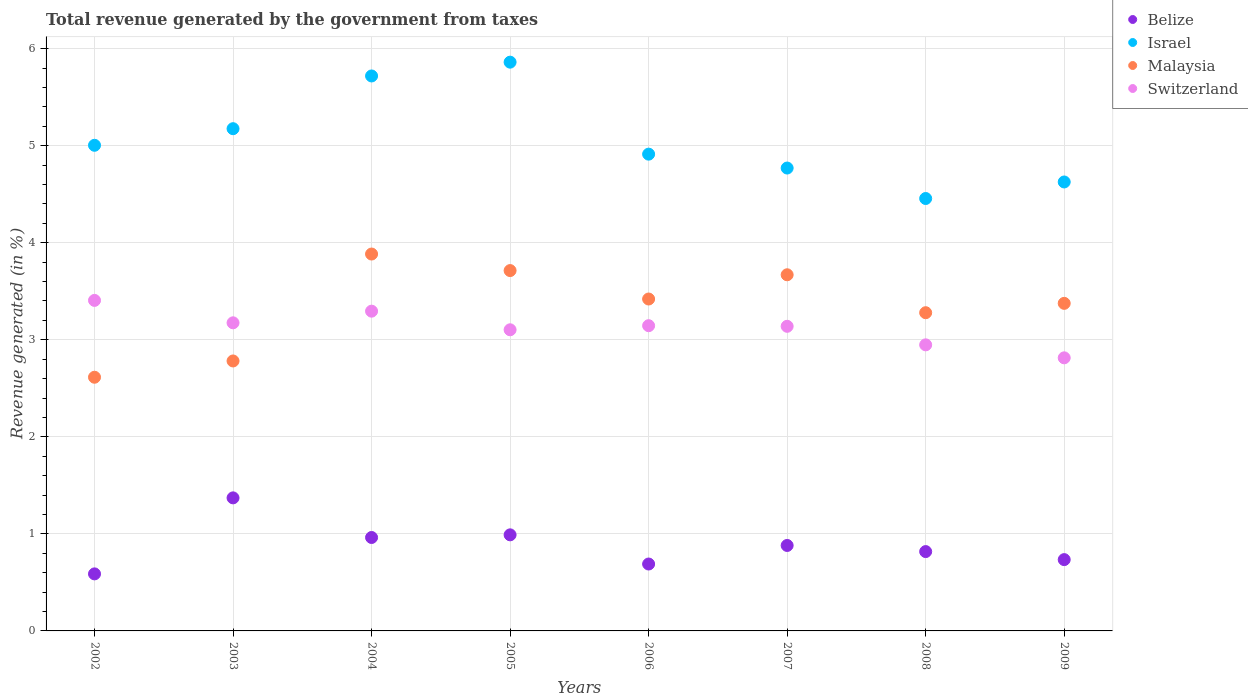How many different coloured dotlines are there?
Provide a succinct answer. 4. What is the total revenue generated in Switzerland in 2009?
Offer a terse response. 2.81. Across all years, what is the maximum total revenue generated in Belize?
Your answer should be compact. 1.37. Across all years, what is the minimum total revenue generated in Israel?
Provide a short and direct response. 4.46. In which year was the total revenue generated in Israel minimum?
Your answer should be very brief. 2008. What is the total total revenue generated in Israel in the graph?
Provide a short and direct response. 40.52. What is the difference between the total revenue generated in Malaysia in 2006 and that in 2007?
Make the answer very short. -0.25. What is the difference between the total revenue generated in Israel in 2008 and the total revenue generated in Belize in 2007?
Ensure brevity in your answer.  3.58. What is the average total revenue generated in Malaysia per year?
Your answer should be very brief. 3.34. In the year 2009, what is the difference between the total revenue generated in Malaysia and total revenue generated in Belize?
Give a very brief answer. 2.64. In how many years, is the total revenue generated in Malaysia greater than 2.4 %?
Keep it short and to the point. 8. What is the ratio of the total revenue generated in Switzerland in 2003 to that in 2004?
Offer a very short reply. 0.96. What is the difference between the highest and the second highest total revenue generated in Switzerland?
Give a very brief answer. 0.11. What is the difference between the highest and the lowest total revenue generated in Belize?
Keep it short and to the point. 0.78. In how many years, is the total revenue generated in Israel greater than the average total revenue generated in Israel taken over all years?
Offer a very short reply. 3. Is it the case that in every year, the sum of the total revenue generated in Israel and total revenue generated in Malaysia  is greater than the sum of total revenue generated in Belize and total revenue generated in Switzerland?
Your answer should be compact. Yes. Is it the case that in every year, the sum of the total revenue generated in Switzerland and total revenue generated in Belize  is greater than the total revenue generated in Malaysia?
Provide a short and direct response. Yes. Does the total revenue generated in Switzerland monotonically increase over the years?
Offer a terse response. No. Is the total revenue generated in Malaysia strictly less than the total revenue generated in Switzerland over the years?
Give a very brief answer. No. Are the values on the major ticks of Y-axis written in scientific E-notation?
Offer a very short reply. No. Does the graph contain any zero values?
Your answer should be very brief. No. Does the graph contain grids?
Your answer should be compact. Yes. Where does the legend appear in the graph?
Make the answer very short. Top right. How many legend labels are there?
Offer a very short reply. 4. What is the title of the graph?
Offer a terse response. Total revenue generated by the government from taxes. Does "Bahrain" appear as one of the legend labels in the graph?
Provide a short and direct response. No. What is the label or title of the X-axis?
Provide a short and direct response. Years. What is the label or title of the Y-axis?
Make the answer very short. Revenue generated (in %). What is the Revenue generated (in %) of Belize in 2002?
Provide a succinct answer. 0.59. What is the Revenue generated (in %) of Israel in 2002?
Keep it short and to the point. 5. What is the Revenue generated (in %) of Malaysia in 2002?
Offer a terse response. 2.61. What is the Revenue generated (in %) of Switzerland in 2002?
Ensure brevity in your answer.  3.41. What is the Revenue generated (in %) in Belize in 2003?
Make the answer very short. 1.37. What is the Revenue generated (in %) in Israel in 2003?
Offer a very short reply. 5.17. What is the Revenue generated (in %) in Malaysia in 2003?
Provide a succinct answer. 2.78. What is the Revenue generated (in %) in Switzerland in 2003?
Keep it short and to the point. 3.17. What is the Revenue generated (in %) of Belize in 2004?
Offer a very short reply. 0.96. What is the Revenue generated (in %) in Israel in 2004?
Provide a short and direct response. 5.72. What is the Revenue generated (in %) in Malaysia in 2004?
Keep it short and to the point. 3.88. What is the Revenue generated (in %) of Switzerland in 2004?
Your answer should be compact. 3.29. What is the Revenue generated (in %) in Belize in 2005?
Provide a succinct answer. 0.99. What is the Revenue generated (in %) in Israel in 2005?
Give a very brief answer. 5.86. What is the Revenue generated (in %) in Malaysia in 2005?
Give a very brief answer. 3.71. What is the Revenue generated (in %) of Switzerland in 2005?
Provide a short and direct response. 3.1. What is the Revenue generated (in %) of Belize in 2006?
Make the answer very short. 0.69. What is the Revenue generated (in %) in Israel in 2006?
Ensure brevity in your answer.  4.91. What is the Revenue generated (in %) in Malaysia in 2006?
Offer a very short reply. 3.42. What is the Revenue generated (in %) of Switzerland in 2006?
Your response must be concise. 3.15. What is the Revenue generated (in %) in Belize in 2007?
Offer a terse response. 0.88. What is the Revenue generated (in %) in Israel in 2007?
Keep it short and to the point. 4.77. What is the Revenue generated (in %) of Malaysia in 2007?
Ensure brevity in your answer.  3.67. What is the Revenue generated (in %) in Switzerland in 2007?
Offer a very short reply. 3.14. What is the Revenue generated (in %) in Belize in 2008?
Your response must be concise. 0.82. What is the Revenue generated (in %) in Israel in 2008?
Offer a very short reply. 4.46. What is the Revenue generated (in %) in Malaysia in 2008?
Give a very brief answer. 3.28. What is the Revenue generated (in %) of Switzerland in 2008?
Offer a very short reply. 2.95. What is the Revenue generated (in %) in Belize in 2009?
Provide a succinct answer. 0.73. What is the Revenue generated (in %) in Israel in 2009?
Your answer should be very brief. 4.63. What is the Revenue generated (in %) of Malaysia in 2009?
Your response must be concise. 3.38. What is the Revenue generated (in %) in Switzerland in 2009?
Ensure brevity in your answer.  2.81. Across all years, what is the maximum Revenue generated (in %) of Belize?
Your response must be concise. 1.37. Across all years, what is the maximum Revenue generated (in %) in Israel?
Provide a short and direct response. 5.86. Across all years, what is the maximum Revenue generated (in %) in Malaysia?
Your answer should be compact. 3.88. Across all years, what is the maximum Revenue generated (in %) of Switzerland?
Ensure brevity in your answer.  3.41. Across all years, what is the minimum Revenue generated (in %) of Belize?
Keep it short and to the point. 0.59. Across all years, what is the minimum Revenue generated (in %) in Israel?
Your answer should be compact. 4.46. Across all years, what is the minimum Revenue generated (in %) of Malaysia?
Provide a short and direct response. 2.61. Across all years, what is the minimum Revenue generated (in %) in Switzerland?
Ensure brevity in your answer.  2.81. What is the total Revenue generated (in %) of Belize in the graph?
Provide a succinct answer. 7.03. What is the total Revenue generated (in %) in Israel in the graph?
Make the answer very short. 40.52. What is the total Revenue generated (in %) of Malaysia in the graph?
Ensure brevity in your answer.  26.74. What is the total Revenue generated (in %) in Switzerland in the graph?
Give a very brief answer. 25.02. What is the difference between the Revenue generated (in %) of Belize in 2002 and that in 2003?
Your answer should be very brief. -0.78. What is the difference between the Revenue generated (in %) of Israel in 2002 and that in 2003?
Ensure brevity in your answer.  -0.17. What is the difference between the Revenue generated (in %) in Malaysia in 2002 and that in 2003?
Offer a very short reply. -0.17. What is the difference between the Revenue generated (in %) of Switzerland in 2002 and that in 2003?
Offer a very short reply. 0.23. What is the difference between the Revenue generated (in %) in Belize in 2002 and that in 2004?
Your response must be concise. -0.38. What is the difference between the Revenue generated (in %) in Israel in 2002 and that in 2004?
Keep it short and to the point. -0.71. What is the difference between the Revenue generated (in %) in Malaysia in 2002 and that in 2004?
Make the answer very short. -1.27. What is the difference between the Revenue generated (in %) of Switzerland in 2002 and that in 2004?
Your answer should be compact. 0.11. What is the difference between the Revenue generated (in %) of Belize in 2002 and that in 2005?
Provide a succinct answer. -0.4. What is the difference between the Revenue generated (in %) of Israel in 2002 and that in 2005?
Offer a terse response. -0.86. What is the difference between the Revenue generated (in %) of Malaysia in 2002 and that in 2005?
Offer a terse response. -1.1. What is the difference between the Revenue generated (in %) of Switzerland in 2002 and that in 2005?
Provide a succinct answer. 0.3. What is the difference between the Revenue generated (in %) of Belize in 2002 and that in 2006?
Provide a short and direct response. -0.1. What is the difference between the Revenue generated (in %) of Israel in 2002 and that in 2006?
Make the answer very short. 0.09. What is the difference between the Revenue generated (in %) in Malaysia in 2002 and that in 2006?
Your answer should be very brief. -0.81. What is the difference between the Revenue generated (in %) in Switzerland in 2002 and that in 2006?
Provide a succinct answer. 0.26. What is the difference between the Revenue generated (in %) of Belize in 2002 and that in 2007?
Provide a succinct answer. -0.29. What is the difference between the Revenue generated (in %) in Israel in 2002 and that in 2007?
Make the answer very short. 0.23. What is the difference between the Revenue generated (in %) of Malaysia in 2002 and that in 2007?
Keep it short and to the point. -1.06. What is the difference between the Revenue generated (in %) in Switzerland in 2002 and that in 2007?
Ensure brevity in your answer.  0.27. What is the difference between the Revenue generated (in %) in Belize in 2002 and that in 2008?
Your answer should be very brief. -0.23. What is the difference between the Revenue generated (in %) of Israel in 2002 and that in 2008?
Offer a terse response. 0.55. What is the difference between the Revenue generated (in %) of Malaysia in 2002 and that in 2008?
Offer a very short reply. -0.67. What is the difference between the Revenue generated (in %) of Switzerland in 2002 and that in 2008?
Your answer should be compact. 0.46. What is the difference between the Revenue generated (in %) in Belize in 2002 and that in 2009?
Provide a succinct answer. -0.15. What is the difference between the Revenue generated (in %) in Israel in 2002 and that in 2009?
Offer a terse response. 0.38. What is the difference between the Revenue generated (in %) of Malaysia in 2002 and that in 2009?
Your answer should be compact. -0.76. What is the difference between the Revenue generated (in %) of Switzerland in 2002 and that in 2009?
Keep it short and to the point. 0.59. What is the difference between the Revenue generated (in %) of Belize in 2003 and that in 2004?
Provide a succinct answer. 0.41. What is the difference between the Revenue generated (in %) in Israel in 2003 and that in 2004?
Give a very brief answer. -0.54. What is the difference between the Revenue generated (in %) of Malaysia in 2003 and that in 2004?
Make the answer very short. -1.1. What is the difference between the Revenue generated (in %) in Switzerland in 2003 and that in 2004?
Your answer should be compact. -0.12. What is the difference between the Revenue generated (in %) in Belize in 2003 and that in 2005?
Provide a short and direct response. 0.38. What is the difference between the Revenue generated (in %) of Israel in 2003 and that in 2005?
Provide a succinct answer. -0.69. What is the difference between the Revenue generated (in %) in Malaysia in 2003 and that in 2005?
Offer a terse response. -0.93. What is the difference between the Revenue generated (in %) in Switzerland in 2003 and that in 2005?
Your answer should be very brief. 0.07. What is the difference between the Revenue generated (in %) of Belize in 2003 and that in 2006?
Offer a very short reply. 0.68. What is the difference between the Revenue generated (in %) of Israel in 2003 and that in 2006?
Your response must be concise. 0.26. What is the difference between the Revenue generated (in %) of Malaysia in 2003 and that in 2006?
Ensure brevity in your answer.  -0.64. What is the difference between the Revenue generated (in %) in Switzerland in 2003 and that in 2006?
Provide a succinct answer. 0.03. What is the difference between the Revenue generated (in %) in Belize in 2003 and that in 2007?
Make the answer very short. 0.49. What is the difference between the Revenue generated (in %) in Israel in 2003 and that in 2007?
Your answer should be very brief. 0.41. What is the difference between the Revenue generated (in %) in Malaysia in 2003 and that in 2007?
Provide a succinct answer. -0.89. What is the difference between the Revenue generated (in %) in Switzerland in 2003 and that in 2007?
Keep it short and to the point. 0.04. What is the difference between the Revenue generated (in %) of Belize in 2003 and that in 2008?
Ensure brevity in your answer.  0.55. What is the difference between the Revenue generated (in %) of Israel in 2003 and that in 2008?
Keep it short and to the point. 0.72. What is the difference between the Revenue generated (in %) of Malaysia in 2003 and that in 2008?
Make the answer very short. -0.5. What is the difference between the Revenue generated (in %) of Switzerland in 2003 and that in 2008?
Ensure brevity in your answer.  0.23. What is the difference between the Revenue generated (in %) in Belize in 2003 and that in 2009?
Your response must be concise. 0.64. What is the difference between the Revenue generated (in %) of Israel in 2003 and that in 2009?
Your answer should be compact. 0.55. What is the difference between the Revenue generated (in %) in Malaysia in 2003 and that in 2009?
Provide a short and direct response. -0.59. What is the difference between the Revenue generated (in %) in Switzerland in 2003 and that in 2009?
Your answer should be compact. 0.36. What is the difference between the Revenue generated (in %) in Belize in 2004 and that in 2005?
Make the answer very short. -0.03. What is the difference between the Revenue generated (in %) of Israel in 2004 and that in 2005?
Offer a terse response. -0.14. What is the difference between the Revenue generated (in %) of Malaysia in 2004 and that in 2005?
Make the answer very short. 0.17. What is the difference between the Revenue generated (in %) of Switzerland in 2004 and that in 2005?
Your response must be concise. 0.19. What is the difference between the Revenue generated (in %) in Belize in 2004 and that in 2006?
Your answer should be compact. 0.27. What is the difference between the Revenue generated (in %) of Israel in 2004 and that in 2006?
Provide a succinct answer. 0.81. What is the difference between the Revenue generated (in %) in Malaysia in 2004 and that in 2006?
Give a very brief answer. 0.46. What is the difference between the Revenue generated (in %) in Switzerland in 2004 and that in 2006?
Your response must be concise. 0.15. What is the difference between the Revenue generated (in %) in Belize in 2004 and that in 2007?
Your answer should be very brief. 0.08. What is the difference between the Revenue generated (in %) in Israel in 2004 and that in 2007?
Ensure brevity in your answer.  0.95. What is the difference between the Revenue generated (in %) of Malaysia in 2004 and that in 2007?
Your response must be concise. 0.21. What is the difference between the Revenue generated (in %) of Switzerland in 2004 and that in 2007?
Your answer should be compact. 0.16. What is the difference between the Revenue generated (in %) in Belize in 2004 and that in 2008?
Provide a short and direct response. 0.15. What is the difference between the Revenue generated (in %) of Israel in 2004 and that in 2008?
Provide a short and direct response. 1.26. What is the difference between the Revenue generated (in %) of Malaysia in 2004 and that in 2008?
Your answer should be compact. 0.6. What is the difference between the Revenue generated (in %) in Switzerland in 2004 and that in 2008?
Your answer should be very brief. 0.35. What is the difference between the Revenue generated (in %) of Belize in 2004 and that in 2009?
Offer a terse response. 0.23. What is the difference between the Revenue generated (in %) of Israel in 2004 and that in 2009?
Keep it short and to the point. 1.09. What is the difference between the Revenue generated (in %) of Malaysia in 2004 and that in 2009?
Provide a short and direct response. 0.51. What is the difference between the Revenue generated (in %) of Switzerland in 2004 and that in 2009?
Offer a very short reply. 0.48. What is the difference between the Revenue generated (in %) of Belize in 2005 and that in 2006?
Make the answer very short. 0.3. What is the difference between the Revenue generated (in %) in Israel in 2005 and that in 2006?
Ensure brevity in your answer.  0.95. What is the difference between the Revenue generated (in %) in Malaysia in 2005 and that in 2006?
Provide a succinct answer. 0.29. What is the difference between the Revenue generated (in %) of Switzerland in 2005 and that in 2006?
Your answer should be compact. -0.04. What is the difference between the Revenue generated (in %) in Belize in 2005 and that in 2007?
Provide a succinct answer. 0.11. What is the difference between the Revenue generated (in %) of Israel in 2005 and that in 2007?
Make the answer very short. 1.09. What is the difference between the Revenue generated (in %) of Malaysia in 2005 and that in 2007?
Provide a succinct answer. 0.04. What is the difference between the Revenue generated (in %) of Switzerland in 2005 and that in 2007?
Your answer should be very brief. -0.04. What is the difference between the Revenue generated (in %) of Belize in 2005 and that in 2008?
Your response must be concise. 0.17. What is the difference between the Revenue generated (in %) of Israel in 2005 and that in 2008?
Provide a succinct answer. 1.4. What is the difference between the Revenue generated (in %) of Malaysia in 2005 and that in 2008?
Provide a succinct answer. 0.43. What is the difference between the Revenue generated (in %) of Switzerland in 2005 and that in 2008?
Your response must be concise. 0.16. What is the difference between the Revenue generated (in %) in Belize in 2005 and that in 2009?
Keep it short and to the point. 0.26. What is the difference between the Revenue generated (in %) in Israel in 2005 and that in 2009?
Ensure brevity in your answer.  1.23. What is the difference between the Revenue generated (in %) of Malaysia in 2005 and that in 2009?
Your answer should be compact. 0.34. What is the difference between the Revenue generated (in %) in Switzerland in 2005 and that in 2009?
Give a very brief answer. 0.29. What is the difference between the Revenue generated (in %) of Belize in 2006 and that in 2007?
Offer a very short reply. -0.19. What is the difference between the Revenue generated (in %) in Israel in 2006 and that in 2007?
Offer a very short reply. 0.14. What is the difference between the Revenue generated (in %) in Malaysia in 2006 and that in 2007?
Your answer should be compact. -0.25. What is the difference between the Revenue generated (in %) of Switzerland in 2006 and that in 2007?
Make the answer very short. 0.01. What is the difference between the Revenue generated (in %) of Belize in 2006 and that in 2008?
Ensure brevity in your answer.  -0.13. What is the difference between the Revenue generated (in %) of Israel in 2006 and that in 2008?
Your answer should be compact. 0.46. What is the difference between the Revenue generated (in %) in Malaysia in 2006 and that in 2008?
Give a very brief answer. 0.14. What is the difference between the Revenue generated (in %) in Switzerland in 2006 and that in 2008?
Make the answer very short. 0.2. What is the difference between the Revenue generated (in %) in Belize in 2006 and that in 2009?
Provide a short and direct response. -0.05. What is the difference between the Revenue generated (in %) of Israel in 2006 and that in 2009?
Give a very brief answer. 0.29. What is the difference between the Revenue generated (in %) of Malaysia in 2006 and that in 2009?
Provide a succinct answer. 0.04. What is the difference between the Revenue generated (in %) in Switzerland in 2006 and that in 2009?
Your answer should be very brief. 0.33. What is the difference between the Revenue generated (in %) in Belize in 2007 and that in 2008?
Ensure brevity in your answer.  0.06. What is the difference between the Revenue generated (in %) of Israel in 2007 and that in 2008?
Provide a succinct answer. 0.31. What is the difference between the Revenue generated (in %) in Malaysia in 2007 and that in 2008?
Make the answer very short. 0.39. What is the difference between the Revenue generated (in %) of Switzerland in 2007 and that in 2008?
Your answer should be very brief. 0.19. What is the difference between the Revenue generated (in %) in Belize in 2007 and that in 2009?
Give a very brief answer. 0.15. What is the difference between the Revenue generated (in %) in Israel in 2007 and that in 2009?
Ensure brevity in your answer.  0.14. What is the difference between the Revenue generated (in %) of Malaysia in 2007 and that in 2009?
Your response must be concise. 0.29. What is the difference between the Revenue generated (in %) of Switzerland in 2007 and that in 2009?
Your response must be concise. 0.32. What is the difference between the Revenue generated (in %) of Belize in 2008 and that in 2009?
Provide a succinct answer. 0.08. What is the difference between the Revenue generated (in %) in Israel in 2008 and that in 2009?
Your answer should be very brief. -0.17. What is the difference between the Revenue generated (in %) of Malaysia in 2008 and that in 2009?
Make the answer very short. -0.1. What is the difference between the Revenue generated (in %) in Switzerland in 2008 and that in 2009?
Your answer should be compact. 0.13. What is the difference between the Revenue generated (in %) of Belize in 2002 and the Revenue generated (in %) of Israel in 2003?
Your answer should be compact. -4.59. What is the difference between the Revenue generated (in %) in Belize in 2002 and the Revenue generated (in %) in Malaysia in 2003?
Provide a short and direct response. -2.19. What is the difference between the Revenue generated (in %) of Belize in 2002 and the Revenue generated (in %) of Switzerland in 2003?
Your answer should be very brief. -2.59. What is the difference between the Revenue generated (in %) of Israel in 2002 and the Revenue generated (in %) of Malaysia in 2003?
Make the answer very short. 2.22. What is the difference between the Revenue generated (in %) of Israel in 2002 and the Revenue generated (in %) of Switzerland in 2003?
Your answer should be very brief. 1.83. What is the difference between the Revenue generated (in %) in Malaysia in 2002 and the Revenue generated (in %) in Switzerland in 2003?
Your answer should be very brief. -0.56. What is the difference between the Revenue generated (in %) of Belize in 2002 and the Revenue generated (in %) of Israel in 2004?
Keep it short and to the point. -5.13. What is the difference between the Revenue generated (in %) of Belize in 2002 and the Revenue generated (in %) of Malaysia in 2004?
Your answer should be compact. -3.3. What is the difference between the Revenue generated (in %) in Belize in 2002 and the Revenue generated (in %) in Switzerland in 2004?
Offer a terse response. -2.71. What is the difference between the Revenue generated (in %) of Israel in 2002 and the Revenue generated (in %) of Malaysia in 2004?
Provide a succinct answer. 1.12. What is the difference between the Revenue generated (in %) of Israel in 2002 and the Revenue generated (in %) of Switzerland in 2004?
Offer a terse response. 1.71. What is the difference between the Revenue generated (in %) of Malaysia in 2002 and the Revenue generated (in %) of Switzerland in 2004?
Ensure brevity in your answer.  -0.68. What is the difference between the Revenue generated (in %) in Belize in 2002 and the Revenue generated (in %) in Israel in 2005?
Your answer should be compact. -5.27. What is the difference between the Revenue generated (in %) of Belize in 2002 and the Revenue generated (in %) of Malaysia in 2005?
Give a very brief answer. -3.13. What is the difference between the Revenue generated (in %) of Belize in 2002 and the Revenue generated (in %) of Switzerland in 2005?
Your response must be concise. -2.52. What is the difference between the Revenue generated (in %) in Israel in 2002 and the Revenue generated (in %) in Malaysia in 2005?
Provide a succinct answer. 1.29. What is the difference between the Revenue generated (in %) of Israel in 2002 and the Revenue generated (in %) of Switzerland in 2005?
Provide a short and direct response. 1.9. What is the difference between the Revenue generated (in %) in Malaysia in 2002 and the Revenue generated (in %) in Switzerland in 2005?
Provide a short and direct response. -0.49. What is the difference between the Revenue generated (in %) of Belize in 2002 and the Revenue generated (in %) of Israel in 2006?
Offer a terse response. -4.32. What is the difference between the Revenue generated (in %) of Belize in 2002 and the Revenue generated (in %) of Malaysia in 2006?
Your answer should be compact. -2.83. What is the difference between the Revenue generated (in %) of Belize in 2002 and the Revenue generated (in %) of Switzerland in 2006?
Offer a very short reply. -2.56. What is the difference between the Revenue generated (in %) in Israel in 2002 and the Revenue generated (in %) in Malaysia in 2006?
Offer a terse response. 1.58. What is the difference between the Revenue generated (in %) of Israel in 2002 and the Revenue generated (in %) of Switzerland in 2006?
Give a very brief answer. 1.86. What is the difference between the Revenue generated (in %) in Malaysia in 2002 and the Revenue generated (in %) in Switzerland in 2006?
Your answer should be very brief. -0.53. What is the difference between the Revenue generated (in %) of Belize in 2002 and the Revenue generated (in %) of Israel in 2007?
Provide a short and direct response. -4.18. What is the difference between the Revenue generated (in %) in Belize in 2002 and the Revenue generated (in %) in Malaysia in 2007?
Offer a very short reply. -3.08. What is the difference between the Revenue generated (in %) of Belize in 2002 and the Revenue generated (in %) of Switzerland in 2007?
Provide a short and direct response. -2.55. What is the difference between the Revenue generated (in %) in Israel in 2002 and the Revenue generated (in %) in Malaysia in 2007?
Provide a succinct answer. 1.33. What is the difference between the Revenue generated (in %) in Israel in 2002 and the Revenue generated (in %) in Switzerland in 2007?
Your answer should be very brief. 1.87. What is the difference between the Revenue generated (in %) in Malaysia in 2002 and the Revenue generated (in %) in Switzerland in 2007?
Offer a terse response. -0.52. What is the difference between the Revenue generated (in %) in Belize in 2002 and the Revenue generated (in %) in Israel in 2008?
Your answer should be very brief. -3.87. What is the difference between the Revenue generated (in %) in Belize in 2002 and the Revenue generated (in %) in Malaysia in 2008?
Ensure brevity in your answer.  -2.69. What is the difference between the Revenue generated (in %) of Belize in 2002 and the Revenue generated (in %) of Switzerland in 2008?
Provide a short and direct response. -2.36. What is the difference between the Revenue generated (in %) of Israel in 2002 and the Revenue generated (in %) of Malaysia in 2008?
Give a very brief answer. 1.73. What is the difference between the Revenue generated (in %) in Israel in 2002 and the Revenue generated (in %) in Switzerland in 2008?
Make the answer very short. 2.06. What is the difference between the Revenue generated (in %) of Malaysia in 2002 and the Revenue generated (in %) of Switzerland in 2008?
Your answer should be compact. -0.33. What is the difference between the Revenue generated (in %) in Belize in 2002 and the Revenue generated (in %) in Israel in 2009?
Provide a short and direct response. -4.04. What is the difference between the Revenue generated (in %) in Belize in 2002 and the Revenue generated (in %) in Malaysia in 2009?
Give a very brief answer. -2.79. What is the difference between the Revenue generated (in %) in Belize in 2002 and the Revenue generated (in %) in Switzerland in 2009?
Ensure brevity in your answer.  -2.23. What is the difference between the Revenue generated (in %) in Israel in 2002 and the Revenue generated (in %) in Malaysia in 2009?
Your response must be concise. 1.63. What is the difference between the Revenue generated (in %) in Israel in 2002 and the Revenue generated (in %) in Switzerland in 2009?
Give a very brief answer. 2.19. What is the difference between the Revenue generated (in %) in Belize in 2003 and the Revenue generated (in %) in Israel in 2004?
Ensure brevity in your answer.  -4.35. What is the difference between the Revenue generated (in %) in Belize in 2003 and the Revenue generated (in %) in Malaysia in 2004?
Provide a succinct answer. -2.51. What is the difference between the Revenue generated (in %) in Belize in 2003 and the Revenue generated (in %) in Switzerland in 2004?
Make the answer very short. -1.92. What is the difference between the Revenue generated (in %) in Israel in 2003 and the Revenue generated (in %) in Malaysia in 2004?
Provide a short and direct response. 1.29. What is the difference between the Revenue generated (in %) in Israel in 2003 and the Revenue generated (in %) in Switzerland in 2004?
Your answer should be compact. 1.88. What is the difference between the Revenue generated (in %) of Malaysia in 2003 and the Revenue generated (in %) of Switzerland in 2004?
Offer a terse response. -0.51. What is the difference between the Revenue generated (in %) of Belize in 2003 and the Revenue generated (in %) of Israel in 2005?
Make the answer very short. -4.49. What is the difference between the Revenue generated (in %) in Belize in 2003 and the Revenue generated (in %) in Malaysia in 2005?
Keep it short and to the point. -2.34. What is the difference between the Revenue generated (in %) in Belize in 2003 and the Revenue generated (in %) in Switzerland in 2005?
Offer a very short reply. -1.73. What is the difference between the Revenue generated (in %) in Israel in 2003 and the Revenue generated (in %) in Malaysia in 2005?
Your answer should be very brief. 1.46. What is the difference between the Revenue generated (in %) of Israel in 2003 and the Revenue generated (in %) of Switzerland in 2005?
Give a very brief answer. 2.07. What is the difference between the Revenue generated (in %) in Malaysia in 2003 and the Revenue generated (in %) in Switzerland in 2005?
Offer a very short reply. -0.32. What is the difference between the Revenue generated (in %) in Belize in 2003 and the Revenue generated (in %) in Israel in 2006?
Ensure brevity in your answer.  -3.54. What is the difference between the Revenue generated (in %) in Belize in 2003 and the Revenue generated (in %) in Malaysia in 2006?
Your answer should be very brief. -2.05. What is the difference between the Revenue generated (in %) of Belize in 2003 and the Revenue generated (in %) of Switzerland in 2006?
Your response must be concise. -1.77. What is the difference between the Revenue generated (in %) of Israel in 2003 and the Revenue generated (in %) of Malaysia in 2006?
Ensure brevity in your answer.  1.75. What is the difference between the Revenue generated (in %) in Israel in 2003 and the Revenue generated (in %) in Switzerland in 2006?
Provide a succinct answer. 2.03. What is the difference between the Revenue generated (in %) in Malaysia in 2003 and the Revenue generated (in %) in Switzerland in 2006?
Your answer should be compact. -0.36. What is the difference between the Revenue generated (in %) in Belize in 2003 and the Revenue generated (in %) in Israel in 2007?
Give a very brief answer. -3.4. What is the difference between the Revenue generated (in %) of Belize in 2003 and the Revenue generated (in %) of Malaysia in 2007?
Provide a short and direct response. -2.3. What is the difference between the Revenue generated (in %) of Belize in 2003 and the Revenue generated (in %) of Switzerland in 2007?
Provide a short and direct response. -1.77. What is the difference between the Revenue generated (in %) of Israel in 2003 and the Revenue generated (in %) of Malaysia in 2007?
Provide a short and direct response. 1.51. What is the difference between the Revenue generated (in %) in Israel in 2003 and the Revenue generated (in %) in Switzerland in 2007?
Your answer should be very brief. 2.04. What is the difference between the Revenue generated (in %) in Malaysia in 2003 and the Revenue generated (in %) in Switzerland in 2007?
Your response must be concise. -0.36. What is the difference between the Revenue generated (in %) in Belize in 2003 and the Revenue generated (in %) in Israel in 2008?
Make the answer very short. -3.08. What is the difference between the Revenue generated (in %) in Belize in 2003 and the Revenue generated (in %) in Malaysia in 2008?
Your response must be concise. -1.91. What is the difference between the Revenue generated (in %) in Belize in 2003 and the Revenue generated (in %) in Switzerland in 2008?
Ensure brevity in your answer.  -1.58. What is the difference between the Revenue generated (in %) in Israel in 2003 and the Revenue generated (in %) in Malaysia in 2008?
Offer a terse response. 1.9. What is the difference between the Revenue generated (in %) in Israel in 2003 and the Revenue generated (in %) in Switzerland in 2008?
Provide a short and direct response. 2.23. What is the difference between the Revenue generated (in %) of Malaysia in 2003 and the Revenue generated (in %) of Switzerland in 2008?
Ensure brevity in your answer.  -0.17. What is the difference between the Revenue generated (in %) in Belize in 2003 and the Revenue generated (in %) in Israel in 2009?
Your answer should be very brief. -3.25. What is the difference between the Revenue generated (in %) of Belize in 2003 and the Revenue generated (in %) of Malaysia in 2009?
Offer a very short reply. -2. What is the difference between the Revenue generated (in %) in Belize in 2003 and the Revenue generated (in %) in Switzerland in 2009?
Provide a succinct answer. -1.44. What is the difference between the Revenue generated (in %) of Israel in 2003 and the Revenue generated (in %) of Malaysia in 2009?
Provide a succinct answer. 1.8. What is the difference between the Revenue generated (in %) in Israel in 2003 and the Revenue generated (in %) in Switzerland in 2009?
Your answer should be very brief. 2.36. What is the difference between the Revenue generated (in %) of Malaysia in 2003 and the Revenue generated (in %) of Switzerland in 2009?
Offer a very short reply. -0.03. What is the difference between the Revenue generated (in %) in Belize in 2004 and the Revenue generated (in %) in Israel in 2005?
Ensure brevity in your answer.  -4.9. What is the difference between the Revenue generated (in %) of Belize in 2004 and the Revenue generated (in %) of Malaysia in 2005?
Give a very brief answer. -2.75. What is the difference between the Revenue generated (in %) in Belize in 2004 and the Revenue generated (in %) in Switzerland in 2005?
Your response must be concise. -2.14. What is the difference between the Revenue generated (in %) of Israel in 2004 and the Revenue generated (in %) of Malaysia in 2005?
Offer a terse response. 2.01. What is the difference between the Revenue generated (in %) of Israel in 2004 and the Revenue generated (in %) of Switzerland in 2005?
Make the answer very short. 2.62. What is the difference between the Revenue generated (in %) of Malaysia in 2004 and the Revenue generated (in %) of Switzerland in 2005?
Your answer should be compact. 0.78. What is the difference between the Revenue generated (in %) of Belize in 2004 and the Revenue generated (in %) of Israel in 2006?
Give a very brief answer. -3.95. What is the difference between the Revenue generated (in %) of Belize in 2004 and the Revenue generated (in %) of Malaysia in 2006?
Your answer should be very brief. -2.46. What is the difference between the Revenue generated (in %) in Belize in 2004 and the Revenue generated (in %) in Switzerland in 2006?
Ensure brevity in your answer.  -2.18. What is the difference between the Revenue generated (in %) in Israel in 2004 and the Revenue generated (in %) in Malaysia in 2006?
Ensure brevity in your answer.  2.3. What is the difference between the Revenue generated (in %) in Israel in 2004 and the Revenue generated (in %) in Switzerland in 2006?
Your answer should be compact. 2.57. What is the difference between the Revenue generated (in %) of Malaysia in 2004 and the Revenue generated (in %) of Switzerland in 2006?
Make the answer very short. 0.74. What is the difference between the Revenue generated (in %) in Belize in 2004 and the Revenue generated (in %) in Israel in 2007?
Your answer should be compact. -3.81. What is the difference between the Revenue generated (in %) in Belize in 2004 and the Revenue generated (in %) in Malaysia in 2007?
Your response must be concise. -2.71. What is the difference between the Revenue generated (in %) of Belize in 2004 and the Revenue generated (in %) of Switzerland in 2007?
Ensure brevity in your answer.  -2.18. What is the difference between the Revenue generated (in %) of Israel in 2004 and the Revenue generated (in %) of Malaysia in 2007?
Provide a succinct answer. 2.05. What is the difference between the Revenue generated (in %) of Israel in 2004 and the Revenue generated (in %) of Switzerland in 2007?
Offer a terse response. 2.58. What is the difference between the Revenue generated (in %) in Malaysia in 2004 and the Revenue generated (in %) in Switzerland in 2007?
Your response must be concise. 0.74. What is the difference between the Revenue generated (in %) of Belize in 2004 and the Revenue generated (in %) of Israel in 2008?
Make the answer very short. -3.49. What is the difference between the Revenue generated (in %) in Belize in 2004 and the Revenue generated (in %) in Malaysia in 2008?
Provide a short and direct response. -2.32. What is the difference between the Revenue generated (in %) in Belize in 2004 and the Revenue generated (in %) in Switzerland in 2008?
Give a very brief answer. -1.99. What is the difference between the Revenue generated (in %) of Israel in 2004 and the Revenue generated (in %) of Malaysia in 2008?
Your answer should be very brief. 2.44. What is the difference between the Revenue generated (in %) in Israel in 2004 and the Revenue generated (in %) in Switzerland in 2008?
Ensure brevity in your answer.  2.77. What is the difference between the Revenue generated (in %) in Malaysia in 2004 and the Revenue generated (in %) in Switzerland in 2008?
Provide a short and direct response. 0.94. What is the difference between the Revenue generated (in %) of Belize in 2004 and the Revenue generated (in %) of Israel in 2009?
Make the answer very short. -3.66. What is the difference between the Revenue generated (in %) in Belize in 2004 and the Revenue generated (in %) in Malaysia in 2009?
Keep it short and to the point. -2.41. What is the difference between the Revenue generated (in %) in Belize in 2004 and the Revenue generated (in %) in Switzerland in 2009?
Give a very brief answer. -1.85. What is the difference between the Revenue generated (in %) of Israel in 2004 and the Revenue generated (in %) of Malaysia in 2009?
Provide a short and direct response. 2.34. What is the difference between the Revenue generated (in %) in Israel in 2004 and the Revenue generated (in %) in Switzerland in 2009?
Offer a very short reply. 2.9. What is the difference between the Revenue generated (in %) in Malaysia in 2004 and the Revenue generated (in %) in Switzerland in 2009?
Offer a terse response. 1.07. What is the difference between the Revenue generated (in %) of Belize in 2005 and the Revenue generated (in %) of Israel in 2006?
Ensure brevity in your answer.  -3.92. What is the difference between the Revenue generated (in %) of Belize in 2005 and the Revenue generated (in %) of Malaysia in 2006?
Offer a terse response. -2.43. What is the difference between the Revenue generated (in %) in Belize in 2005 and the Revenue generated (in %) in Switzerland in 2006?
Ensure brevity in your answer.  -2.16. What is the difference between the Revenue generated (in %) of Israel in 2005 and the Revenue generated (in %) of Malaysia in 2006?
Offer a terse response. 2.44. What is the difference between the Revenue generated (in %) of Israel in 2005 and the Revenue generated (in %) of Switzerland in 2006?
Your response must be concise. 2.72. What is the difference between the Revenue generated (in %) of Malaysia in 2005 and the Revenue generated (in %) of Switzerland in 2006?
Your response must be concise. 0.57. What is the difference between the Revenue generated (in %) in Belize in 2005 and the Revenue generated (in %) in Israel in 2007?
Offer a very short reply. -3.78. What is the difference between the Revenue generated (in %) of Belize in 2005 and the Revenue generated (in %) of Malaysia in 2007?
Ensure brevity in your answer.  -2.68. What is the difference between the Revenue generated (in %) in Belize in 2005 and the Revenue generated (in %) in Switzerland in 2007?
Make the answer very short. -2.15. What is the difference between the Revenue generated (in %) of Israel in 2005 and the Revenue generated (in %) of Malaysia in 2007?
Give a very brief answer. 2.19. What is the difference between the Revenue generated (in %) in Israel in 2005 and the Revenue generated (in %) in Switzerland in 2007?
Offer a terse response. 2.72. What is the difference between the Revenue generated (in %) of Malaysia in 2005 and the Revenue generated (in %) of Switzerland in 2007?
Provide a short and direct response. 0.57. What is the difference between the Revenue generated (in %) in Belize in 2005 and the Revenue generated (in %) in Israel in 2008?
Make the answer very short. -3.47. What is the difference between the Revenue generated (in %) in Belize in 2005 and the Revenue generated (in %) in Malaysia in 2008?
Ensure brevity in your answer.  -2.29. What is the difference between the Revenue generated (in %) in Belize in 2005 and the Revenue generated (in %) in Switzerland in 2008?
Your response must be concise. -1.96. What is the difference between the Revenue generated (in %) in Israel in 2005 and the Revenue generated (in %) in Malaysia in 2008?
Provide a succinct answer. 2.58. What is the difference between the Revenue generated (in %) in Israel in 2005 and the Revenue generated (in %) in Switzerland in 2008?
Offer a terse response. 2.91. What is the difference between the Revenue generated (in %) of Malaysia in 2005 and the Revenue generated (in %) of Switzerland in 2008?
Your answer should be very brief. 0.77. What is the difference between the Revenue generated (in %) in Belize in 2005 and the Revenue generated (in %) in Israel in 2009?
Your answer should be compact. -3.64. What is the difference between the Revenue generated (in %) in Belize in 2005 and the Revenue generated (in %) in Malaysia in 2009?
Your answer should be compact. -2.39. What is the difference between the Revenue generated (in %) of Belize in 2005 and the Revenue generated (in %) of Switzerland in 2009?
Your answer should be very brief. -1.82. What is the difference between the Revenue generated (in %) of Israel in 2005 and the Revenue generated (in %) of Malaysia in 2009?
Offer a terse response. 2.49. What is the difference between the Revenue generated (in %) in Israel in 2005 and the Revenue generated (in %) in Switzerland in 2009?
Give a very brief answer. 3.05. What is the difference between the Revenue generated (in %) in Malaysia in 2005 and the Revenue generated (in %) in Switzerland in 2009?
Keep it short and to the point. 0.9. What is the difference between the Revenue generated (in %) in Belize in 2006 and the Revenue generated (in %) in Israel in 2007?
Give a very brief answer. -4.08. What is the difference between the Revenue generated (in %) of Belize in 2006 and the Revenue generated (in %) of Malaysia in 2007?
Make the answer very short. -2.98. What is the difference between the Revenue generated (in %) of Belize in 2006 and the Revenue generated (in %) of Switzerland in 2007?
Provide a short and direct response. -2.45. What is the difference between the Revenue generated (in %) in Israel in 2006 and the Revenue generated (in %) in Malaysia in 2007?
Your response must be concise. 1.24. What is the difference between the Revenue generated (in %) of Israel in 2006 and the Revenue generated (in %) of Switzerland in 2007?
Your answer should be compact. 1.77. What is the difference between the Revenue generated (in %) in Malaysia in 2006 and the Revenue generated (in %) in Switzerland in 2007?
Offer a very short reply. 0.28. What is the difference between the Revenue generated (in %) in Belize in 2006 and the Revenue generated (in %) in Israel in 2008?
Offer a terse response. -3.77. What is the difference between the Revenue generated (in %) of Belize in 2006 and the Revenue generated (in %) of Malaysia in 2008?
Your response must be concise. -2.59. What is the difference between the Revenue generated (in %) in Belize in 2006 and the Revenue generated (in %) in Switzerland in 2008?
Give a very brief answer. -2.26. What is the difference between the Revenue generated (in %) of Israel in 2006 and the Revenue generated (in %) of Malaysia in 2008?
Provide a short and direct response. 1.63. What is the difference between the Revenue generated (in %) of Israel in 2006 and the Revenue generated (in %) of Switzerland in 2008?
Offer a very short reply. 1.96. What is the difference between the Revenue generated (in %) in Malaysia in 2006 and the Revenue generated (in %) in Switzerland in 2008?
Ensure brevity in your answer.  0.47. What is the difference between the Revenue generated (in %) in Belize in 2006 and the Revenue generated (in %) in Israel in 2009?
Offer a terse response. -3.94. What is the difference between the Revenue generated (in %) of Belize in 2006 and the Revenue generated (in %) of Malaysia in 2009?
Offer a terse response. -2.69. What is the difference between the Revenue generated (in %) of Belize in 2006 and the Revenue generated (in %) of Switzerland in 2009?
Offer a very short reply. -2.12. What is the difference between the Revenue generated (in %) in Israel in 2006 and the Revenue generated (in %) in Malaysia in 2009?
Offer a very short reply. 1.54. What is the difference between the Revenue generated (in %) in Israel in 2006 and the Revenue generated (in %) in Switzerland in 2009?
Your answer should be very brief. 2.1. What is the difference between the Revenue generated (in %) in Malaysia in 2006 and the Revenue generated (in %) in Switzerland in 2009?
Give a very brief answer. 0.61. What is the difference between the Revenue generated (in %) in Belize in 2007 and the Revenue generated (in %) in Israel in 2008?
Offer a very short reply. -3.58. What is the difference between the Revenue generated (in %) in Belize in 2007 and the Revenue generated (in %) in Malaysia in 2008?
Provide a succinct answer. -2.4. What is the difference between the Revenue generated (in %) in Belize in 2007 and the Revenue generated (in %) in Switzerland in 2008?
Provide a short and direct response. -2.07. What is the difference between the Revenue generated (in %) in Israel in 2007 and the Revenue generated (in %) in Malaysia in 2008?
Keep it short and to the point. 1.49. What is the difference between the Revenue generated (in %) in Israel in 2007 and the Revenue generated (in %) in Switzerland in 2008?
Ensure brevity in your answer.  1.82. What is the difference between the Revenue generated (in %) of Malaysia in 2007 and the Revenue generated (in %) of Switzerland in 2008?
Provide a succinct answer. 0.72. What is the difference between the Revenue generated (in %) of Belize in 2007 and the Revenue generated (in %) of Israel in 2009?
Keep it short and to the point. -3.75. What is the difference between the Revenue generated (in %) in Belize in 2007 and the Revenue generated (in %) in Malaysia in 2009?
Provide a short and direct response. -2.49. What is the difference between the Revenue generated (in %) in Belize in 2007 and the Revenue generated (in %) in Switzerland in 2009?
Your response must be concise. -1.93. What is the difference between the Revenue generated (in %) in Israel in 2007 and the Revenue generated (in %) in Malaysia in 2009?
Offer a terse response. 1.39. What is the difference between the Revenue generated (in %) of Israel in 2007 and the Revenue generated (in %) of Switzerland in 2009?
Give a very brief answer. 1.96. What is the difference between the Revenue generated (in %) of Malaysia in 2007 and the Revenue generated (in %) of Switzerland in 2009?
Give a very brief answer. 0.86. What is the difference between the Revenue generated (in %) in Belize in 2008 and the Revenue generated (in %) in Israel in 2009?
Provide a succinct answer. -3.81. What is the difference between the Revenue generated (in %) in Belize in 2008 and the Revenue generated (in %) in Malaysia in 2009?
Offer a very short reply. -2.56. What is the difference between the Revenue generated (in %) of Belize in 2008 and the Revenue generated (in %) of Switzerland in 2009?
Give a very brief answer. -2. What is the difference between the Revenue generated (in %) of Israel in 2008 and the Revenue generated (in %) of Malaysia in 2009?
Your answer should be compact. 1.08. What is the difference between the Revenue generated (in %) of Israel in 2008 and the Revenue generated (in %) of Switzerland in 2009?
Offer a very short reply. 1.64. What is the difference between the Revenue generated (in %) in Malaysia in 2008 and the Revenue generated (in %) in Switzerland in 2009?
Your answer should be very brief. 0.47. What is the average Revenue generated (in %) of Belize per year?
Offer a very short reply. 0.88. What is the average Revenue generated (in %) in Israel per year?
Provide a short and direct response. 5.07. What is the average Revenue generated (in %) in Malaysia per year?
Your answer should be compact. 3.34. What is the average Revenue generated (in %) in Switzerland per year?
Offer a terse response. 3.13. In the year 2002, what is the difference between the Revenue generated (in %) of Belize and Revenue generated (in %) of Israel?
Your response must be concise. -4.42. In the year 2002, what is the difference between the Revenue generated (in %) of Belize and Revenue generated (in %) of Malaysia?
Ensure brevity in your answer.  -2.03. In the year 2002, what is the difference between the Revenue generated (in %) in Belize and Revenue generated (in %) in Switzerland?
Provide a short and direct response. -2.82. In the year 2002, what is the difference between the Revenue generated (in %) in Israel and Revenue generated (in %) in Malaysia?
Ensure brevity in your answer.  2.39. In the year 2002, what is the difference between the Revenue generated (in %) in Israel and Revenue generated (in %) in Switzerland?
Offer a very short reply. 1.6. In the year 2002, what is the difference between the Revenue generated (in %) of Malaysia and Revenue generated (in %) of Switzerland?
Provide a succinct answer. -0.79. In the year 2003, what is the difference between the Revenue generated (in %) in Belize and Revenue generated (in %) in Israel?
Your answer should be very brief. -3.8. In the year 2003, what is the difference between the Revenue generated (in %) in Belize and Revenue generated (in %) in Malaysia?
Your response must be concise. -1.41. In the year 2003, what is the difference between the Revenue generated (in %) of Belize and Revenue generated (in %) of Switzerland?
Provide a succinct answer. -1.8. In the year 2003, what is the difference between the Revenue generated (in %) in Israel and Revenue generated (in %) in Malaysia?
Ensure brevity in your answer.  2.39. In the year 2003, what is the difference between the Revenue generated (in %) of Israel and Revenue generated (in %) of Switzerland?
Offer a very short reply. 2. In the year 2003, what is the difference between the Revenue generated (in %) of Malaysia and Revenue generated (in %) of Switzerland?
Give a very brief answer. -0.39. In the year 2004, what is the difference between the Revenue generated (in %) of Belize and Revenue generated (in %) of Israel?
Your answer should be compact. -4.76. In the year 2004, what is the difference between the Revenue generated (in %) of Belize and Revenue generated (in %) of Malaysia?
Offer a terse response. -2.92. In the year 2004, what is the difference between the Revenue generated (in %) in Belize and Revenue generated (in %) in Switzerland?
Your response must be concise. -2.33. In the year 2004, what is the difference between the Revenue generated (in %) in Israel and Revenue generated (in %) in Malaysia?
Ensure brevity in your answer.  1.83. In the year 2004, what is the difference between the Revenue generated (in %) of Israel and Revenue generated (in %) of Switzerland?
Your answer should be compact. 2.42. In the year 2004, what is the difference between the Revenue generated (in %) of Malaysia and Revenue generated (in %) of Switzerland?
Provide a succinct answer. 0.59. In the year 2005, what is the difference between the Revenue generated (in %) of Belize and Revenue generated (in %) of Israel?
Your response must be concise. -4.87. In the year 2005, what is the difference between the Revenue generated (in %) of Belize and Revenue generated (in %) of Malaysia?
Your answer should be compact. -2.72. In the year 2005, what is the difference between the Revenue generated (in %) in Belize and Revenue generated (in %) in Switzerland?
Your answer should be very brief. -2.11. In the year 2005, what is the difference between the Revenue generated (in %) of Israel and Revenue generated (in %) of Malaysia?
Provide a succinct answer. 2.15. In the year 2005, what is the difference between the Revenue generated (in %) in Israel and Revenue generated (in %) in Switzerland?
Offer a terse response. 2.76. In the year 2005, what is the difference between the Revenue generated (in %) of Malaysia and Revenue generated (in %) of Switzerland?
Keep it short and to the point. 0.61. In the year 2006, what is the difference between the Revenue generated (in %) of Belize and Revenue generated (in %) of Israel?
Offer a very short reply. -4.22. In the year 2006, what is the difference between the Revenue generated (in %) of Belize and Revenue generated (in %) of Malaysia?
Your answer should be very brief. -2.73. In the year 2006, what is the difference between the Revenue generated (in %) in Belize and Revenue generated (in %) in Switzerland?
Your answer should be compact. -2.46. In the year 2006, what is the difference between the Revenue generated (in %) in Israel and Revenue generated (in %) in Malaysia?
Give a very brief answer. 1.49. In the year 2006, what is the difference between the Revenue generated (in %) in Israel and Revenue generated (in %) in Switzerland?
Your response must be concise. 1.77. In the year 2006, what is the difference between the Revenue generated (in %) in Malaysia and Revenue generated (in %) in Switzerland?
Offer a very short reply. 0.27. In the year 2007, what is the difference between the Revenue generated (in %) of Belize and Revenue generated (in %) of Israel?
Give a very brief answer. -3.89. In the year 2007, what is the difference between the Revenue generated (in %) in Belize and Revenue generated (in %) in Malaysia?
Your answer should be very brief. -2.79. In the year 2007, what is the difference between the Revenue generated (in %) of Belize and Revenue generated (in %) of Switzerland?
Your answer should be very brief. -2.26. In the year 2007, what is the difference between the Revenue generated (in %) in Israel and Revenue generated (in %) in Malaysia?
Provide a short and direct response. 1.1. In the year 2007, what is the difference between the Revenue generated (in %) in Israel and Revenue generated (in %) in Switzerland?
Provide a short and direct response. 1.63. In the year 2007, what is the difference between the Revenue generated (in %) of Malaysia and Revenue generated (in %) of Switzerland?
Your answer should be compact. 0.53. In the year 2008, what is the difference between the Revenue generated (in %) of Belize and Revenue generated (in %) of Israel?
Ensure brevity in your answer.  -3.64. In the year 2008, what is the difference between the Revenue generated (in %) in Belize and Revenue generated (in %) in Malaysia?
Make the answer very short. -2.46. In the year 2008, what is the difference between the Revenue generated (in %) in Belize and Revenue generated (in %) in Switzerland?
Your response must be concise. -2.13. In the year 2008, what is the difference between the Revenue generated (in %) in Israel and Revenue generated (in %) in Malaysia?
Provide a succinct answer. 1.18. In the year 2008, what is the difference between the Revenue generated (in %) of Israel and Revenue generated (in %) of Switzerland?
Keep it short and to the point. 1.51. In the year 2008, what is the difference between the Revenue generated (in %) in Malaysia and Revenue generated (in %) in Switzerland?
Make the answer very short. 0.33. In the year 2009, what is the difference between the Revenue generated (in %) in Belize and Revenue generated (in %) in Israel?
Your answer should be very brief. -3.89. In the year 2009, what is the difference between the Revenue generated (in %) in Belize and Revenue generated (in %) in Malaysia?
Offer a terse response. -2.64. In the year 2009, what is the difference between the Revenue generated (in %) of Belize and Revenue generated (in %) of Switzerland?
Ensure brevity in your answer.  -2.08. In the year 2009, what is the difference between the Revenue generated (in %) of Israel and Revenue generated (in %) of Malaysia?
Provide a succinct answer. 1.25. In the year 2009, what is the difference between the Revenue generated (in %) in Israel and Revenue generated (in %) in Switzerland?
Offer a very short reply. 1.81. In the year 2009, what is the difference between the Revenue generated (in %) in Malaysia and Revenue generated (in %) in Switzerland?
Give a very brief answer. 0.56. What is the ratio of the Revenue generated (in %) in Belize in 2002 to that in 2003?
Offer a terse response. 0.43. What is the ratio of the Revenue generated (in %) of Malaysia in 2002 to that in 2003?
Your response must be concise. 0.94. What is the ratio of the Revenue generated (in %) of Switzerland in 2002 to that in 2003?
Your response must be concise. 1.07. What is the ratio of the Revenue generated (in %) of Belize in 2002 to that in 2004?
Provide a succinct answer. 0.61. What is the ratio of the Revenue generated (in %) of Israel in 2002 to that in 2004?
Your response must be concise. 0.88. What is the ratio of the Revenue generated (in %) of Malaysia in 2002 to that in 2004?
Give a very brief answer. 0.67. What is the ratio of the Revenue generated (in %) in Switzerland in 2002 to that in 2004?
Offer a terse response. 1.03. What is the ratio of the Revenue generated (in %) of Belize in 2002 to that in 2005?
Your response must be concise. 0.59. What is the ratio of the Revenue generated (in %) in Israel in 2002 to that in 2005?
Keep it short and to the point. 0.85. What is the ratio of the Revenue generated (in %) in Malaysia in 2002 to that in 2005?
Ensure brevity in your answer.  0.7. What is the ratio of the Revenue generated (in %) of Switzerland in 2002 to that in 2005?
Make the answer very short. 1.1. What is the ratio of the Revenue generated (in %) in Belize in 2002 to that in 2006?
Ensure brevity in your answer.  0.85. What is the ratio of the Revenue generated (in %) of Israel in 2002 to that in 2006?
Your answer should be very brief. 1.02. What is the ratio of the Revenue generated (in %) in Malaysia in 2002 to that in 2006?
Make the answer very short. 0.76. What is the ratio of the Revenue generated (in %) of Switzerland in 2002 to that in 2006?
Your response must be concise. 1.08. What is the ratio of the Revenue generated (in %) in Belize in 2002 to that in 2007?
Give a very brief answer. 0.67. What is the ratio of the Revenue generated (in %) of Israel in 2002 to that in 2007?
Give a very brief answer. 1.05. What is the ratio of the Revenue generated (in %) of Malaysia in 2002 to that in 2007?
Ensure brevity in your answer.  0.71. What is the ratio of the Revenue generated (in %) of Switzerland in 2002 to that in 2007?
Your response must be concise. 1.08. What is the ratio of the Revenue generated (in %) of Belize in 2002 to that in 2008?
Provide a succinct answer. 0.72. What is the ratio of the Revenue generated (in %) in Israel in 2002 to that in 2008?
Provide a succinct answer. 1.12. What is the ratio of the Revenue generated (in %) in Malaysia in 2002 to that in 2008?
Give a very brief answer. 0.8. What is the ratio of the Revenue generated (in %) in Switzerland in 2002 to that in 2008?
Ensure brevity in your answer.  1.16. What is the ratio of the Revenue generated (in %) in Belize in 2002 to that in 2009?
Provide a succinct answer. 0.8. What is the ratio of the Revenue generated (in %) of Israel in 2002 to that in 2009?
Your answer should be very brief. 1.08. What is the ratio of the Revenue generated (in %) in Malaysia in 2002 to that in 2009?
Give a very brief answer. 0.77. What is the ratio of the Revenue generated (in %) in Switzerland in 2002 to that in 2009?
Provide a short and direct response. 1.21. What is the ratio of the Revenue generated (in %) of Belize in 2003 to that in 2004?
Give a very brief answer. 1.42. What is the ratio of the Revenue generated (in %) of Israel in 2003 to that in 2004?
Your response must be concise. 0.91. What is the ratio of the Revenue generated (in %) of Malaysia in 2003 to that in 2004?
Offer a very short reply. 0.72. What is the ratio of the Revenue generated (in %) of Switzerland in 2003 to that in 2004?
Ensure brevity in your answer.  0.96. What is the ratio of the Revenue generated (in %) in Belize in 2003 to that in 2005?
Make the answer very short. 1.38. What is the ratio of the Revenue generated (in %) of Israel in 2003 to that in 2005?
Keep it short and to the point. 0.88. What is the ratio of the Revenue generated (in %) of Malaysia in 2003 to that in 2005?
Your response must be concise. 0.75. What is the ratio of the Revenue generated (in %) of Switzerland in 2003 to that in 2005?
Provide a short and direct response. 1.02. What is the ratio of the Revenue generated (in %) of Belize in 2003 to that in 2006?
Keep it short and to the point. 1.99. What is the ratio of the Revenue generated (in %) of Israel in 2003 to that in 2006?
Your response must be concise. 1.05. What is the ratio of the Revenue generated (in %) of Malaysia in 2003 to that in 2006?
Ensure brevity in your answer.  0.81. What is the ratio of the Revenue generated (in %) of Switzerland in 2003 to that in 2006?
Offer a very short reply. 1.01. What is the ratio of the Revenue generated (in %) of Belize in 2003 to that in 2007?
Offer a terse response. 1.56. What is the ratio of the Revenue generated (in %) in Israel in 2003 to that in 2007?
Ensure brevity in your answer.  1.08. What is the ratio of the Revenue generated (in %) in Malaysia in 2003 to that in 2007?
Keep it short and to the point. 0.76. What is the ratio of the Revenue generated (in %) in Switzerland in 2003 to that in 2007?
Provide a short and direct response. 1.01. What is the ratio of the Revenue generated (in %) in Belize in 2003 to that in 2008?
Provide a short and direct response. 1.68. What is the ratio of the Revenue generated (in %) in Israel in 2003 to that in 2008?
Ensure brevity in your answer.  1.16. What is the ratio of the Revenue generated (in %) in Malaysia in 2003 to that in 2008?
Offer a terse response. 0.85. What is the ratio of the Revenue generated (in %) in Switzerland in 2003 to that in 2008?
Your response must be concise. 1.08. What is the ratio of the Revenue generated (in %) of Belize in 2003 to that in 2009?
Ensure brevity in your answer.  1.87. What is the ratio of the Revenue generated (in %) of Israel in 2003 to that in 2009?
Make the answer very short. 1.12. What is the ratio of the Revenue generated (in %) in Malaysia in 2003 to that in 2009?
Make the answer very short. 0.82. What is the ratio of the Revenue generated (in %) of Switzerland in 2003 to that in 2009?
Your response must be concise. 1.13. What is the ratio of the Revenue generated (in %) in Belize in 2004 to that in 2005?
Keep it short and to the point. 0.97. What is the ratio of the Revenue generated (in %) in Israel in 2004 to that in 2005?
Offer a very short reply. 0.98. What is the ratio of the Revenue generated (in %) in Malaysia in 2004 to that in 2005?
Your answer should be very brief. 1.05. What is the ratio of the Revenue generated (in %) in Switzerland in 2004 to that in 2005?
Give a very brief answer. 1.06. What is the ratio of the Revenue generated (in %) in Belize in 2004 to that in 2006?
Make the answer very short. 1.4. What is the ratio of the Revenue generated (in %) in Israel in 2004 to that in 2006?
Provide a short and direct response. 1.16. What is the ratio of the Revenue generated (in %) of Malaysia in 2004 to that in 2006?
Make the answer very short. 1.14. What is the ratio of the Revenue generated (in %) of Switzerland in 2004 to that in 2006?
Give a very brief answer. 1.05. What is the ratio of the Revenue generated (in %) of Belize in 2004 to that in 2007?
Your answer should be compact. 1.09. What is the ratio of the Revenue generated (in %) of Israel in 2004 to that in 2007?
Give a very brief answer. 1.2. What is the ratio of the Revenue generated (in %) in Malaysia in 2004 to that in 2007?
Ensure brevity in your answer.  1.06. What is the ratio of the Revenue generated (in %) of Switzerland in 2004 to that in 2007?
Your response must be concise. 1.05. What is the ratio of the Revenue generated (in %) of Belize in 2004 to that in 2008?
Your answer should be very brief. 1.18. What is the ratio of the Revenue generated (in %) of Israel in 2004 to that in 2008?
Your answer should be compact. 1.28. What is the ratio of the Revenue generated (in %) of Malaysia in 2004 to that in 2008?
Make the answer very short. 1.18. What is the ratio of the Revenue generated (in %) of Switzerland in 2004 to that in 2008?
Make the answer very short. 1.12. What is the ratio of the Revenue generated (in %) of Belize in 2004 to that in 2009?
Your answer should be very brief. 1.31. What is the ratio of the Revenue generated (in %) of Israel in 2004 to that in 2009?
Keep it short and to the point. 1.24. What is the ratio of the Revenue generated (in %) of Malaysia in 2004 to that in 2009?
Provide a short and direct response. 1.15. What is the ratio of the Revenue generated (in %) in Switzerland in 2004 to that in 2009?
Your answer should be compact. 1.17. What is the ratio of the Revenue generated (in %) of Belize in 2005 to that in 2006?
Ensure brevity in your answer.  1.44. What is the ratio of the Revenue generated (in %) of Israel in 2005 to that in 2006?
Offer a very short reply. 1.19. What is the ratio of the Revenue generated (in %) of Malaysia in 2005 to that in 2006?
Your answer should be very brief. 1.09. What is the ratio of the Revenue generated (in %) in Switzerland in 2005 to that in 2006?
Keep it short and to the point. 0.99. What is the ratio of the Revenue generated (in %) in Belize in 2005 to that in 2007?
Ensure brevity in your answer.  1.12. What is the ratio of the Revenue generated (in %) in Israel in 2005 to that in 2007?
Make the answer very short. 1.23. What is the ratio of the Revenue generated (in %) of Malaysia in 2005 to that in 2007?
Keep it short and to the point. 1.01. What is the ratio of the Revenue generated (in %) of Switzerland in 2005 to that in 2007?
Provide a short and direct response. 0.99. What is the ratio of the Revenue generated (in %) in Belize in 2005 to that in 2008?
Your response must be concise. 1.21. What is the ratio of the Revenue generated (in %) in Israel in 2005 to that in 2008?
Your answer should be very brief. 1.32. What is the ratio of the Revenue generated (in %) of Malaysia in 2005 to that in 2008?
Your answer should be compact. 1.13. What is the ratio of the Revenue generated (in %) of Switzerland in 2005 to that in 2008?
Give a very brief answer. 1.05. What is the ratio of the Revenue generated (in %) of Belize in 2005 to that in 2009?
Your answer should be compact. 1.35. What is the ratio of the Revenue generated (in %) of Israel in 2005 to that in 2009?
Ensure brevity in your answer.  1.27. What is the ratio of the Revenue generated (in %) in Malaysia in 2005 to that in 2009?
Provide a succinct answer. 1.1. What is the ratio of the Revenue generated (in %) in Switzerland in 2005 to that in 2009?
Provide a succinct answer. 1.1. What is the ratio of the Revenue generated (in %) in Belize in 2006 to that in 2007?
Keep it short and to the point. 0.78. What is the ratio of the Revenue generated (in %) of Israel in 2006 to that in 2007?
Offer a terse response. 1.03. What is the ratio of the Revenue generated (in %) of Malaysia in 2006 to that in 2007?
Offer a terse response. 0.93. What is the ratio of the Revenue generated (in %) in Belize in 2006 to that in 2008?
Make the answer very short. 0.84. What is the ratio of the Revenue generated (in %) of Israel in 2006 to that in 2008?
Your response must be concise. 1.1. What is the ratio of the Revenue generated (in %) of Malaysia in 2006 to that in 2008?
Provide a short and direct response. 1.04. What is the ratio of the Revenue generated (in %) in Switzerland in 2006 to that in 2008?
Provide a short and direct response. 1.07. What is the ratio of the Revenue generated (in %) in Belize in 2006 to that in 2009?
Offer a very short reply. 0.94. What is the ratio of the Revenue generated (in %) of Israel in 2006 to that in 2009?
Provide a succinct answer. 1.06. What is the ratio of the Revenue generated (in %) in Malaysia in 2006 to that in 2009?
Ensure brevity in your answer.  1.01. What is the ratio of the Revenue generated (in %) of Switzerland in 2006 to that in 2009?
Ensure brevity in your answer.  1.12. What is the ratio of the Revenue generated (in %) of Belize in 2007 to that in 2008?
Your answer should be very brief. 1.08. What is the ratio of the Revenue generated (in %) of Israel in 2007 to that in 2008?
Offer a very short reply. 1.07. What is the ratio of the Revenue generated (in %) in Malaysia in 2007 to that in 2008?
Your answer should be compact. 1.12. What is the ratio of the Revenue generated (in %) of Switzerland in 2007 to that in 2008?
Give a very brief answer. 1.06. What is the ratio of the Revenue generated (in %) in Belize in 2007 to that in 2009?
Make the answer very short. 1.2. What is the ratio of the Revenue generated (in %) of Israel in 2007 to that in 2009?
Provide a succinct answer. 1.03. What is the ratio of the Revenue generated (in %) in Malaysia in 2007 to that in 2009?
Give a very brief answer. 1.09. What is the ratio of the Revenue generated (in %) of Switzerland in 2007 to that in 2009?
Your response must be concise. 1.12. What is the ratio of the Revenue generated (in %) of Belize in 2008 to that in 2009?
Provide a succinct answer. 1.11. What is the ratio of the Revenue generated (in %) in Israel in 2008 to that in 2009?
Offer a very short reply. 0.96. What is the ratio of the Revenue generated (in %) of Malaysia in 2008 to that in 2009?
Your answer should be compact. 0.97. What is the ratio of the Revenue generated (in %) in Switzerland in 2008 to that in 2009?
Make the answer very short. 1.05. What is the difference between the highest and the second highest Revenue generated (in %) of Belize?
Give a very brief answer. 0.38. What is the difference between the highest and the second highest Revenue generated (in %) of Israel?
Make the answer very short. 0.14. What is the difference between the highest and the second highest Revenue generated (in %) of Malaysia?
Ensure brevity in your answer.  0.17. What is the difference between the highest and the second highest Revenue generated (in %) in Switzerland?
Keep it short and to the point. 0.11. What is the difference between the highest and the lowest Revenue generated (in %) of Belize?
Your response must be concise. 0.78. What is the difference between the highest and the lowest Revenue generated (in %) in Israel?
Give a very brief answer. 1.4. What is the difference between the highest and the lowest Revenue generated (in %) of Malaysia?
Provide a short and direct response. 1.27. What is the difference between the highest and the lowest Revenue generated (in %) in Switzerland?
Provide a succinct answer. 0.59. 